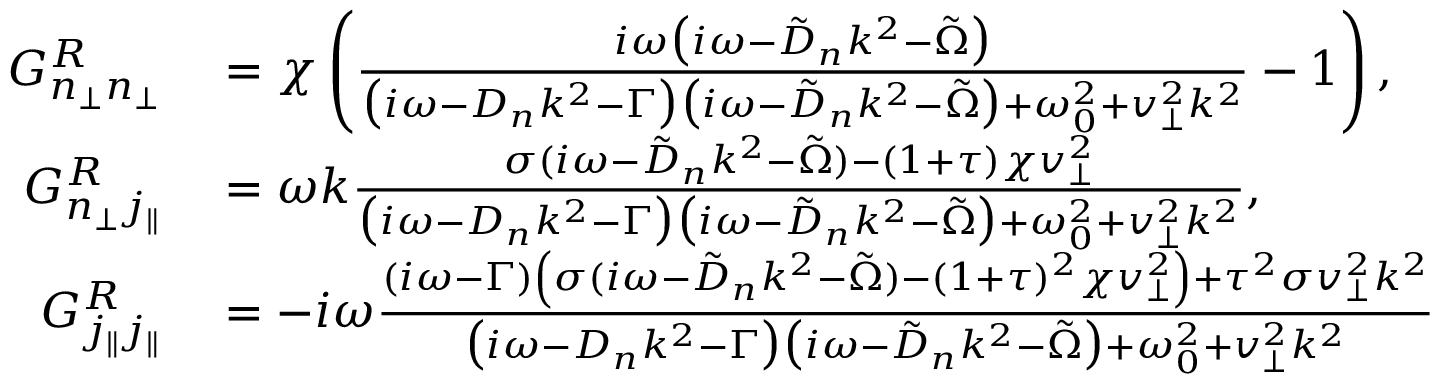Convert formula to latex. <formula><loc_0><loc_0><loc_500><loc_500>\begin{array} { r l } { G _ { n _ { \perp } n _ { \perp } } ^ { R } } & = \chi \left ( \frac { i \omega \left ( i \omega - \tilde { D } _ { n } k ^ { 2 } - \tilde { \Omega } \right ) } { \left ( i \omega - D _ { n } k ^ { 2 } - \Gamma \right ) \left ( i \omega - \tilde { D } _ { n } k ^ { 2 } - \tilde { \Omega } \right ) + \omega _ { 0 } ^ { 2 } + v _ { \perp } ^ { 2 } k ^ { 2 } } - 1 \right ) , } \\ { G _ { n _ { \perp } j _ { \| } } ^ { R } } & = \omega k \frac { \sigma ( i \omega - \tilde { D } _ { n } k ^ { 2 } - \tilde { \Omega } ) - ( 1 + \tau ) \chi v _ { \perp } ^ { 2 } } { { \left ( i \omega - D _ { n } k ^ { 2 } - \Gamma \right ) \left ( i \omega - \tilde { D } _ { n } k ^ { 2 } - \tilde { \Omega } \right ) + \omega _ { 0 } ^ { 2 } + v _ { \perp } ^ { 2 } k ^ { 2 } } } , } \\ { G _ { j _ { \| } j _ { \| } } ^ { R } } & = - i \omega \frac { ( i \omega - \Gamma ) \left ( \sigma ( i \omega - \tilde { D } _ { n } k ^ { 2 } - \tilde { \Omega } ) - ( 1 + \tau ) ^ { 2 } \chi v _ { \perp } ^ { 2 } \right ) + \tau ^ { 2 } \sigma v _ { \perp } ^ { 2 } k ^ { 2 } } { \left ( i \omega - D _ { n } k ^ { 2 } - \Gamma \right ) \left ( i \omega - \tilde { D } _ { n } k ^ { 2 } - \tilde { \Omega } \right ) + \omega _ { 0 } ^ { 2 } + v _ { \perp } ^ { 2 } k ^ { 2 } } } \end{array}</formula> 